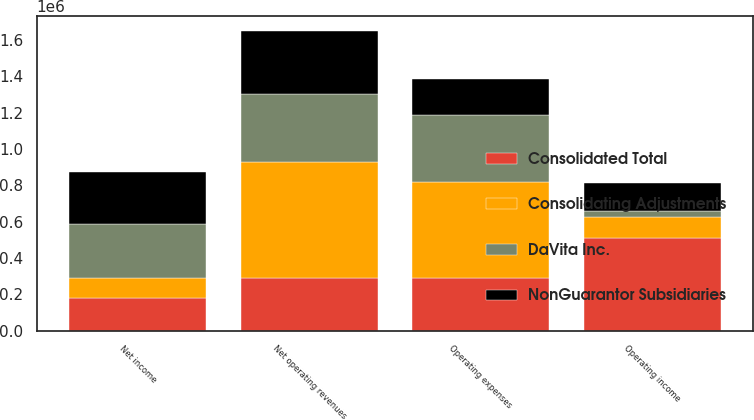Convert chart to OTSL. <chart><loc_0><loc_0><loc_500><loc_500><stacked_bar_chart><ecel><fcel>Net operating revenues<fcel>Operating expenses<fcel>Operating income<fcel>Net income<nl><fcel>NonGuarantor Subsidiaries<fcel>347087<fcel>196367<fcel>150720<fcel>289691<nl><fcel>Consolidated Total<fcel>291292<fcel>291292<fcel>512199<fcel>181172<nl><fcel>Consolidating Adjustments<fcel>639690<fcel>527344<fcel>112346<fcel>111722<nl><fcel>DaVita Inc.<fcel>369478<fcel>369478<fcel>35833<fcel>292894<nl></chart> 